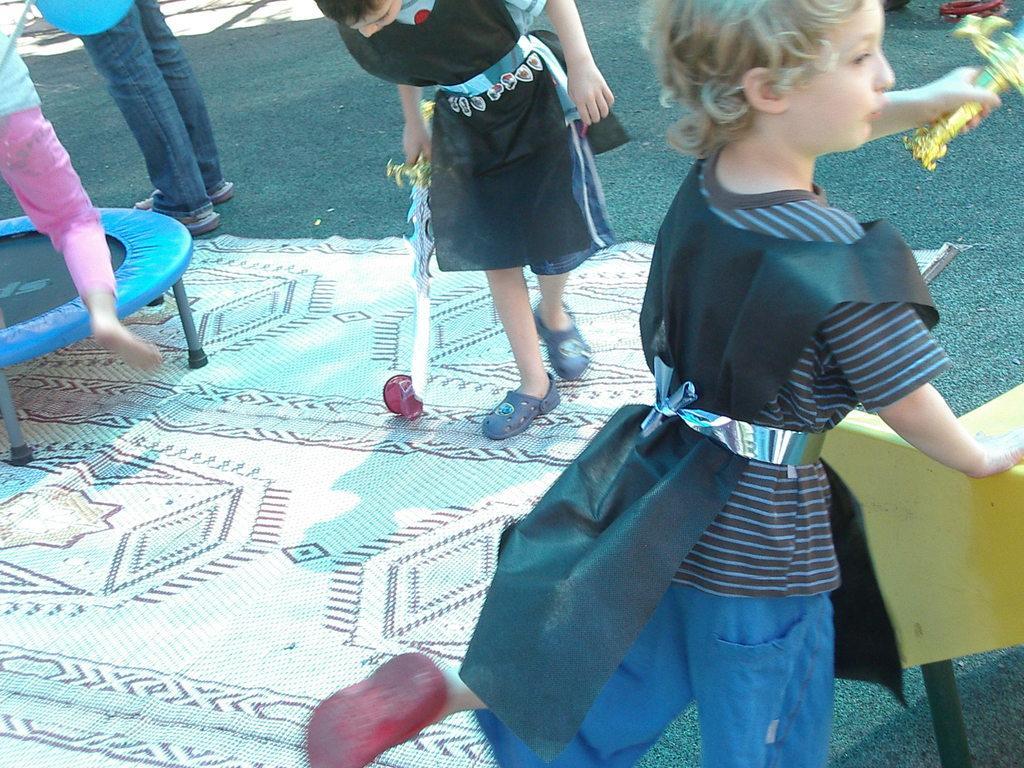Could you give a brief overview of what you see in this image? In this image I can see few children are standing. On the right side of this image I can see a yellow colour thing and on the left side I can see a blue and black colour trampoline. I can also see a mattress on the ground and I can see two children are holding plastic swords. 